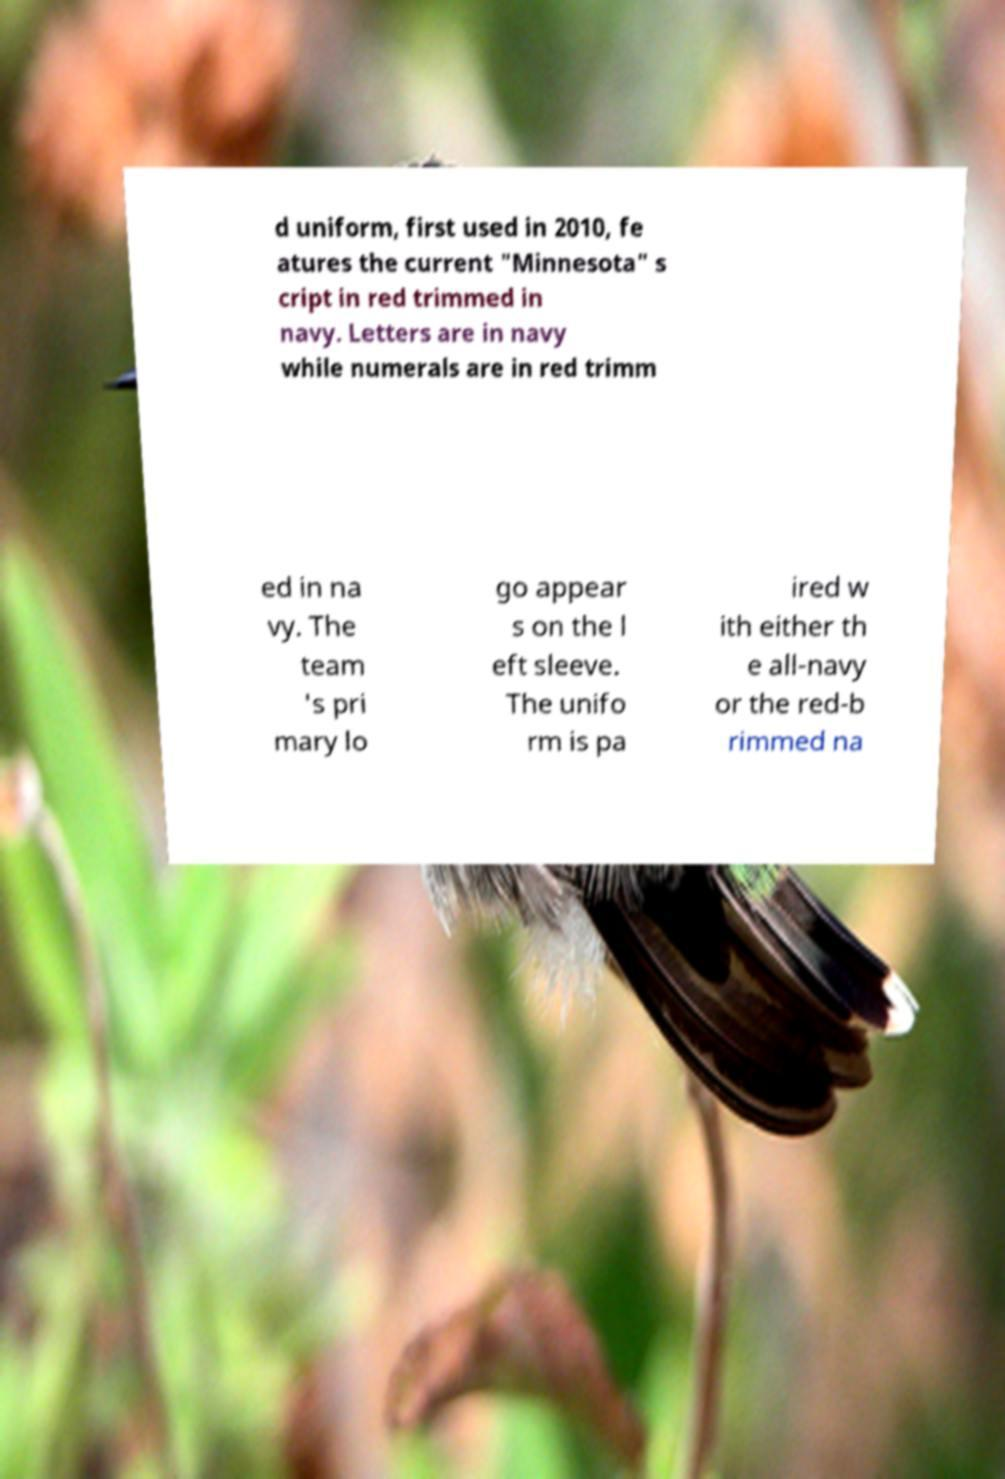For documentation purposes, I need the text within this image transcribed. Could you provide that? d uniform, first used in 2010, fe atures the current "Minnesota" s cript in red trimmed in navy. Letters are in navy while numerals are in red trimm ed in na vy. The team 's pri mary lo go appear s on the l eft sleeve. The unifo rm is pa ired w ith either th e all-navy or the red-b rimmed na 